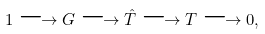Convert formula to latex. <formula><loc_0><loc_0><loc_500><loc_500>1 \longrightarrow G \longrightarrow \hat { T } \longrightarrow T \longrightarrow 0 ,</formula> 